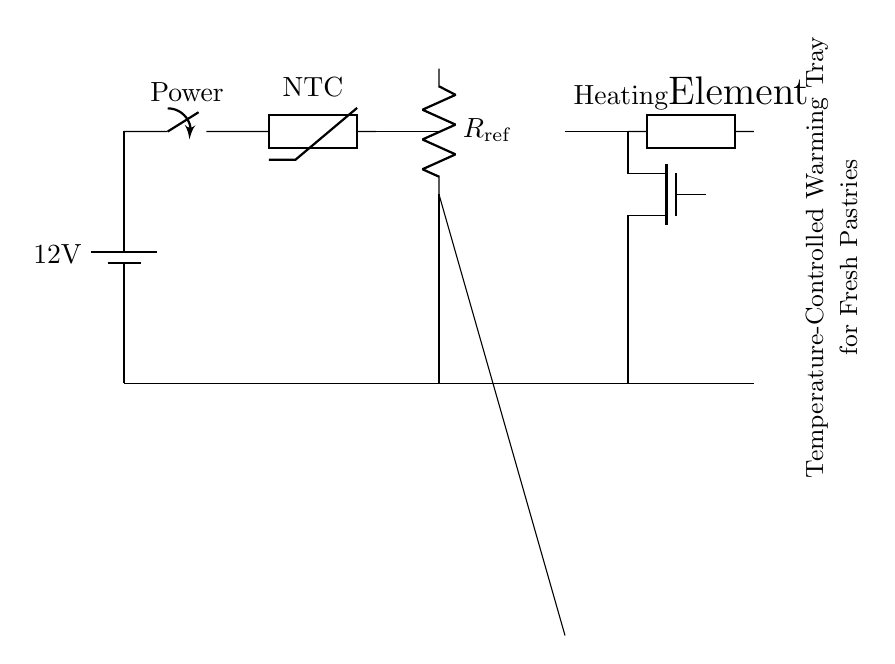What is the voltage of this circuit? The voltage is 12 volts, as indicated by the battery symbol in the circuit diagram.
Answer: 12 volts What type of thermistor is used in this circuit? The thermistor used is a Negative Temperature Coefficient (NTC) type, which is noted directly next to the thermistor symbol in the diagram.
Answer: NTC What component controls the heating element? The component that controls the heating element is the MOSFET, which receives a control signal based on the comparator's output. The connection can be traced from the comparator to the MOSFET in the circuit.
Answer: MOSFET How many main components are directly involved in temperature control? There are three main components involved: the thermistor, comparator, and MOSFET. The thermistor senses temperature, the comparator processes the signal, and the MOSFET controls the heating element based on that signal.
Answer: Three What is the purpose of the resistor labeled R_ref? The resistor labeled R_ref serves as a reference voltage in the comparator circuit, allowing it to compare the voltage from the thermistor to a predetermined value to determine if the heating element should be activated.
Answer: Reference voltage What happens when the temperature rises above a certain threshold? When the temperature rises above a certain threshold, the comparator will send a high signal to the MOSFET, turning it on. This allows current to flow to the heating element, which will then heat the pastries.
Answer: Heating element turns on What is the function of the battery in this circuit? The battery provides the necessary power supply for the entire circuit, delivering 12 volts to operate all components, including the thermistor, comparator, and MOSFET.
Answer: Power supply 